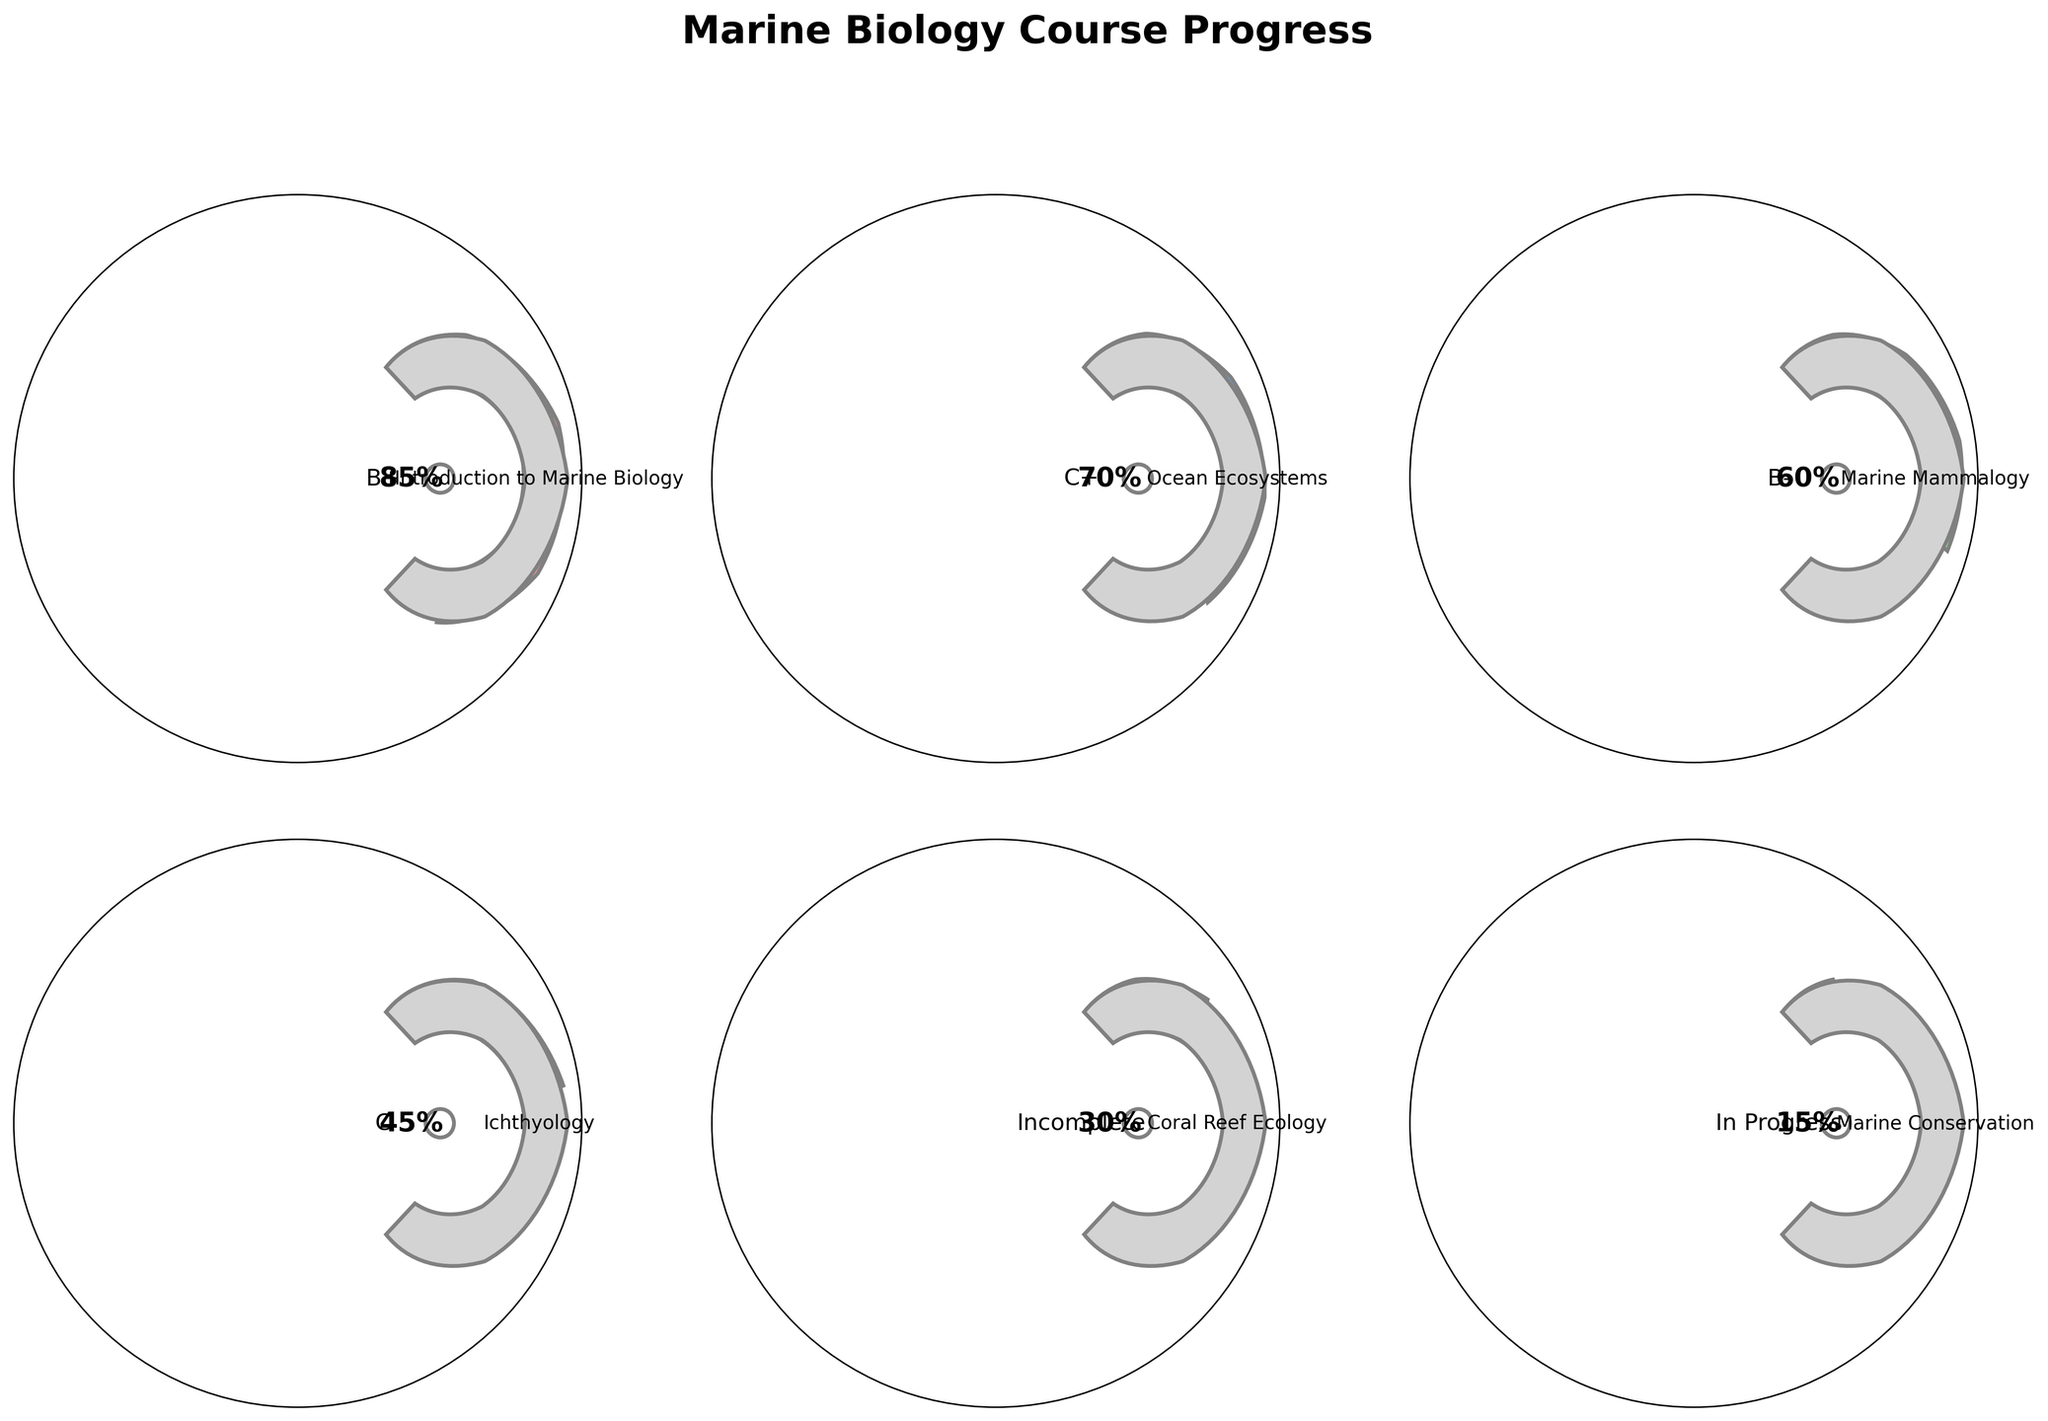Which course has the highest completion percentage? Look for the gauge with the largest completion percentage label. "Introduction to Marine Biology" shows 85%.
Answer: Introduction to Marine Biology What grade did I receive in "Ocean Ecosystems"? Find the gauge marked "Ocean Ecosystems" and check the grade text below the completion percentage, which is "C+."
Answer: C+ Which course is currently in progress? Courses that are still ongoing are labeled as "In Progress." "Marine Conservation" is marked as "In Progress."
Answer: Marine Conservation What is the combined completion percentage for "Ichthyology" and "Coral Reef Ecology"? Add the completion percentages of "Ichthyology" (45%) and "Coral Reef Ecology" (30%). 45% + 30% = 75%.
Answer: 75% What is the difference in completion percentage between the course with the highest completion and the one with the lowest? Subtract the lowest completion percentage ("Marine Conservation" at 15%) from the highest completion percentage ("Introduction to Marine Biology" at 85%). 85% - 15% = 70%.
Answer: 70% How many courses are fully completed? Count the gauges without "Incomplete" or "In Progress" labels and 100% is considered completed. There are "Introduction to Marine Biology" (85%), "Ocean Ecosystems" (70%), "Marine Mammalogy" (60%), and "Ichthyology" (45%).
Answer: 4 Which course has the lowest completion percentage among those with a grade assigned? Exclude courses marked as "Incomplete" or "In Progress." "Ichthyology" shows the lowest completion percentage of 45% among courses with a grade.
Answer: Ichthyology If the average mark for full completion is 90% and above, which courses are below this threshold? Identify courses with completion percentages below 90%. All courses listed ("Introduction to Marine Biology" at 85%, "Ocean Ecosystems" at 70%, "Marine Mammalogy" at 60%, "Ichthyology" at 45%, "Coral Reef Ecology" at 30%, and "Marine Conservation" at 15%) are below 90%.
Answer: All courses What is the average completion percentage of all courses? Sum all completion percentages (85% + 70% + 60% + 45% + 30% + 15%) and divide by the number of values (6). (85 + 70 + 60 + 45 + 30 + 15) / 6 = 50.83%.
Answer: 50.83% 